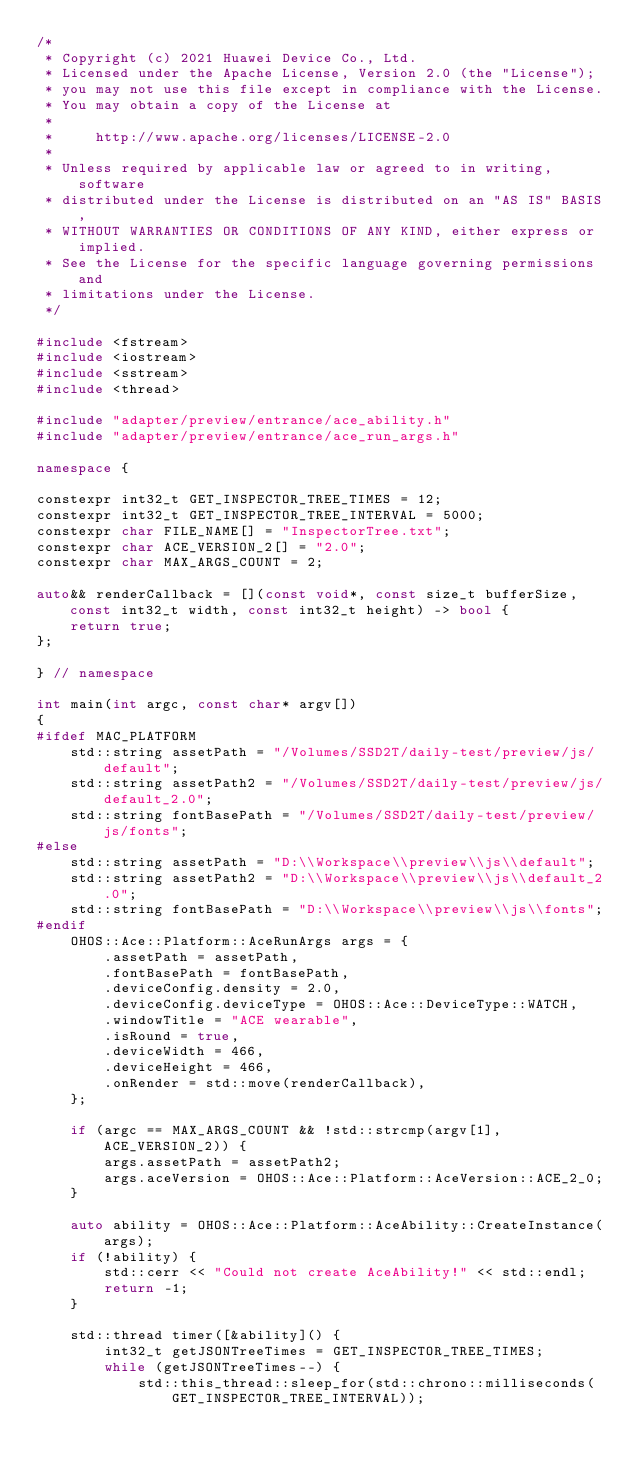<code> <loc_0><loc_0><loc_500><loc_500><_C++_>/*
 * Copyright (c) 2021 Huawei Device Co., Ltd.
 * Licensed under the Apache License, Version 2.0 (the "License");
 * you may not use this file except in compliance with the License.
 * You may obtain a copy of the License at
 *
 *     http://www.apache.org/licenses/LICENSE-2.0
 *
 * Unless required by applicable law or agreed to in writing, software
 * distributed under the License is distributed on an "AS IS" BASIS,
 * WITHOUT WARRANTIES OR CONDITIONS OF ANY KIND, either express or implied.
 * See the License for the specific language governing permissions and
 * limitations under the License.
 */

#include <fstream>
#include <iostream>
#include <sstream>
#include <thread>

#include "adapter/preview/entrance/ace_ability.h"
#include "adapter/preview/entrance/ace_run_args.h"

namespace {

constexpr int32_t GET_INSPECTOR_TREE_TIMES = 12;
constexpr int32_t GET_INSPECTOR_TREE_INTERVAL = 5000;
constexpr char FILE_NAME[] = "InspectorTree.txt";
constexpr char ACE_VERSION_2[] = "2.0";
constexpr char MAX_ARGS_COUNT = 2;

auto&& renderCallback = [](const void*, const size_t bufferSize, const int32_t width, const int32_t height) -> bool {
    return true;
};

} // namespace

int main(int argc, const char* argv[])
{
#ifdef MAC_PLATFORM
    std::string assetPath = "/Volumes/SSD2T/daily-test/preview/js/default";
    std::string assetPath2 = "/Volumes/SSD2T/daily-test/preview/js/default_2.0";
    std::string fontBasePath = "/Volumes/SSD2T/daily-test/preview/js/fonts";
#else
    std::string assetPath = "D:\\Workspace\\preview\\js\\default";
    std::string assetPath2 = "D:\\Workspace\\preview\\js\\default_2.0";
    std::string fontBasePath = "D:\\Workspace\\preview\\js\\fonts";
#endif
    OHOS::Ace::Platform::AceRunArgs args = {
        .assetPath = assetPath,
        .fontBasePath = fontBasePath,
        .deviceConfig.density = 2.0,
        .deviceConfig.deviceType = OHOS::Ace::DeviceType::WATCH,
        .windowTitle = "ACE wearable",
        .isRound = true,
        .deviceWidth = 466,
        .deviceHeight = 466,
        .onRender = std::move(renderCallback),
    };

    if (argc == MAX_ARGS_COUNT && !std::strcmp(argv[1], ACE_VERSION_2)) {
        args.assetPath = assetPath2;
        args.aceVersion = OHOS::Ace::Platform::AceVersion::ACE_2_0;
    }

    auto ability = OHOS::Ace::Platform::AceAbility::CreateInstance(args);
    if (!ability) {
        std::cerr << "Could not create AceAbility!" << std::endl;
        return -1;
    }

    std::thread timer([&ability]() {
        int32_t getJSONTreeTimes = GET_INSPECTOR_TREE_TIMES;
        while (getJSONTreeTimes--) {
            std::this_thread::sleep_for(std::chrono::milliseconds(GET_INSPECTOR_TREE_INTERVAL));</code> 